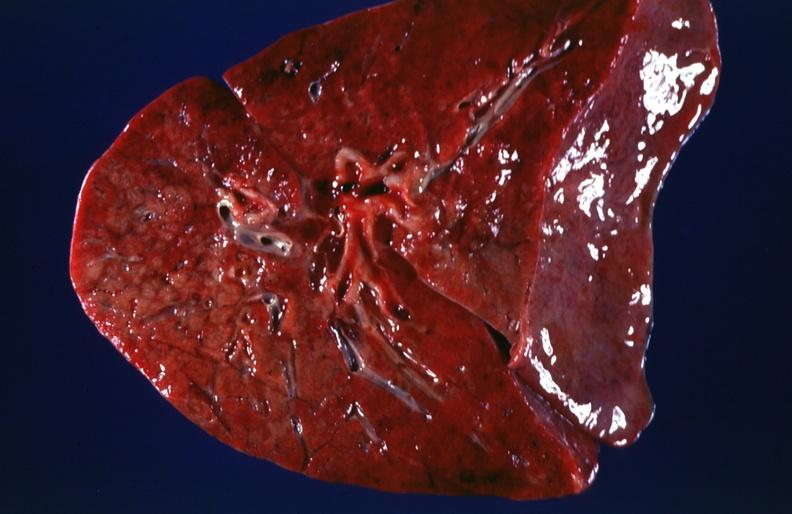what does this image show?
Answer the question using a single word or phrase. Lung 